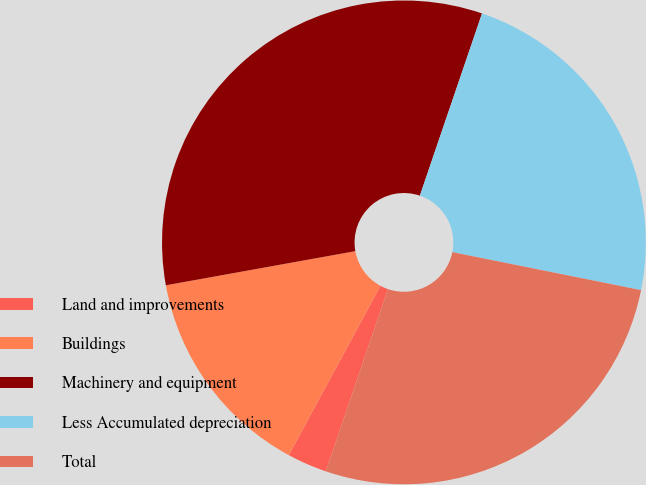Convert chart to OTSL. <chart><loc_0><loc_0><loc_500><loc_500><pie_chart><fcel>Land and improvements<fcel>Buildings<fcel>Machinery and equipment<fcel>Less Accumulated depreciation<fcel>Total<nl><fcel>2.66%<fcel>14.27%<fcel>33.07%<fcel>22.93%<fcel>27.07%<nl></chart> 